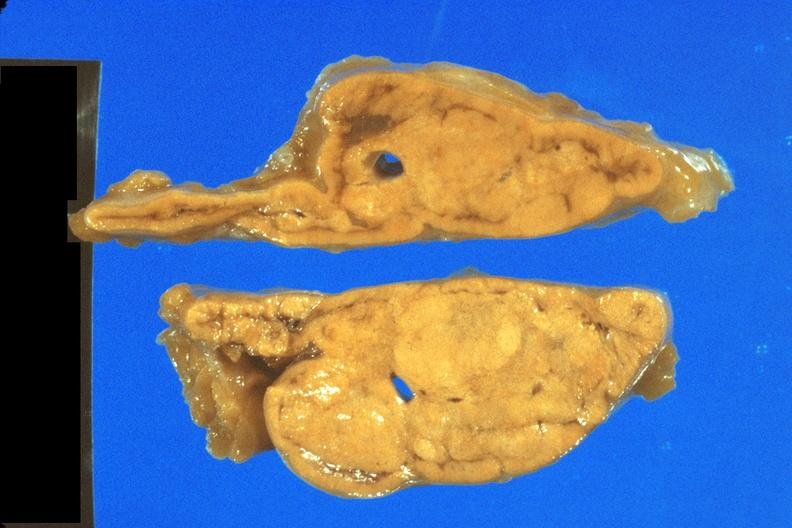s natural color present?
Answer the question using a single word or phrase. No 